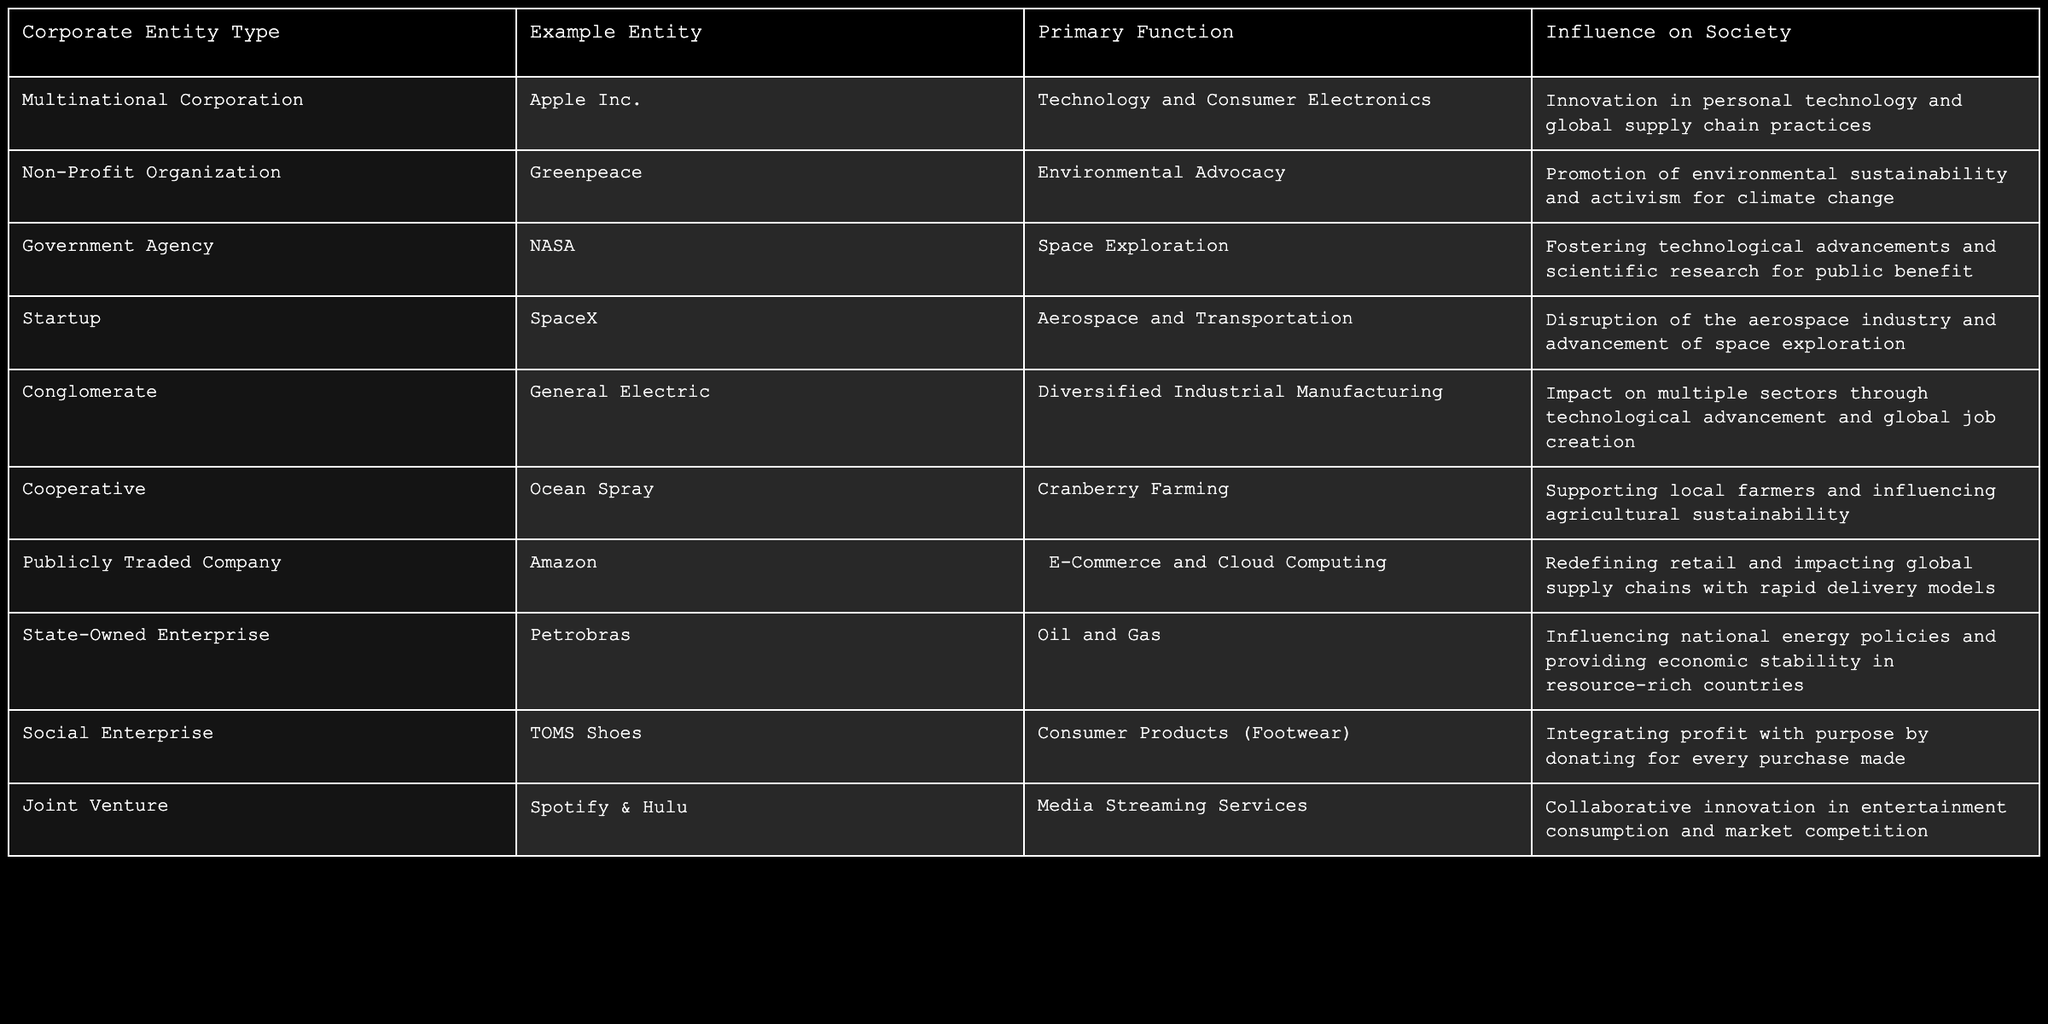What type of corporate entity is SpaceX? SpaceX is listed under the "Startup" category in the table.
Answer: Startup What is the primary function of Greenpeace? According to the table, Greenpeace's primary function is "Environmental Advocacy."
Answer: Environmental Advocacy Which corporate entity focuses on aerospace and transportation? The table shows that SpaceX is the corporate entity that focuses on aerospace and transportation.
Answer: SpaceX Does Amazon primarily operate in the technology sector? The table categorizes Amazon as an "E-Commerce and Cloud Computing" company, indicating its main focus is not solely on technology.
Answer: No What influence does Apple Inc. have on society? The table mentions that Apple Inc. influences society through "Innovation in personal technology and global supply chain practices."
Answer: Innovation in technology and global supply chains How many corporate entities listed in the table are involved in environmental sustainability? Greenpeace is the only entity listed with a function related to environmental sustainability, as indicated in the table.
Answer: 1 Is there a corporate entity in the table that integrates profit with purpose? The table shows TOMS Shoes, a Social Enterprise, integrates profit with purpose by donating for every purchase made.
Answer: Yes Which corporate entity is associated with space exploration and technology advancements? The table indicates that NASA is associated with space exploration and fostering technological advancements.
Answer: NASA What influence do cooperatives such as Ocean Spray have on agriculture? The table states that Ocean Spray supports local farmers and influences agricultural sustainability, elucidating its impact on agriculture.
Answer: Supporting local farmers Which corporate entity has a collaborative relationship with Spotify? The table identifies the joint venture of Spotify & Hulu in media streaming services.
Answer: Spotify & Hulu How do conglomerates like General Electric impact multiple sectors? According to the table, conglomerates like General Electric impact multiple sectors through "technological advancement and global job creation."
Answer: Technological advancement and job creation 